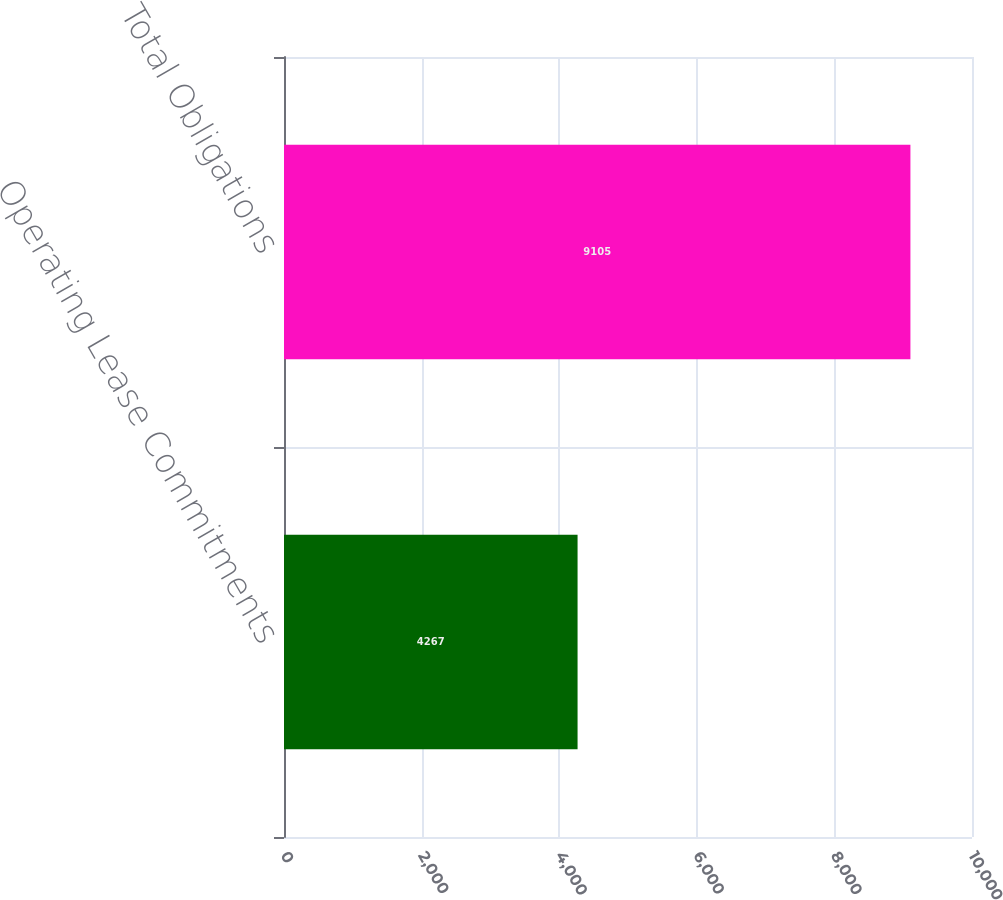<chart> <loc_0><loc_0><loc_500><loc_500><bar_chart><fcel>Operating Lease Commitments<fcel>Total Obligations<nl><fcel>4267<fcel>9105<nl></chart> 